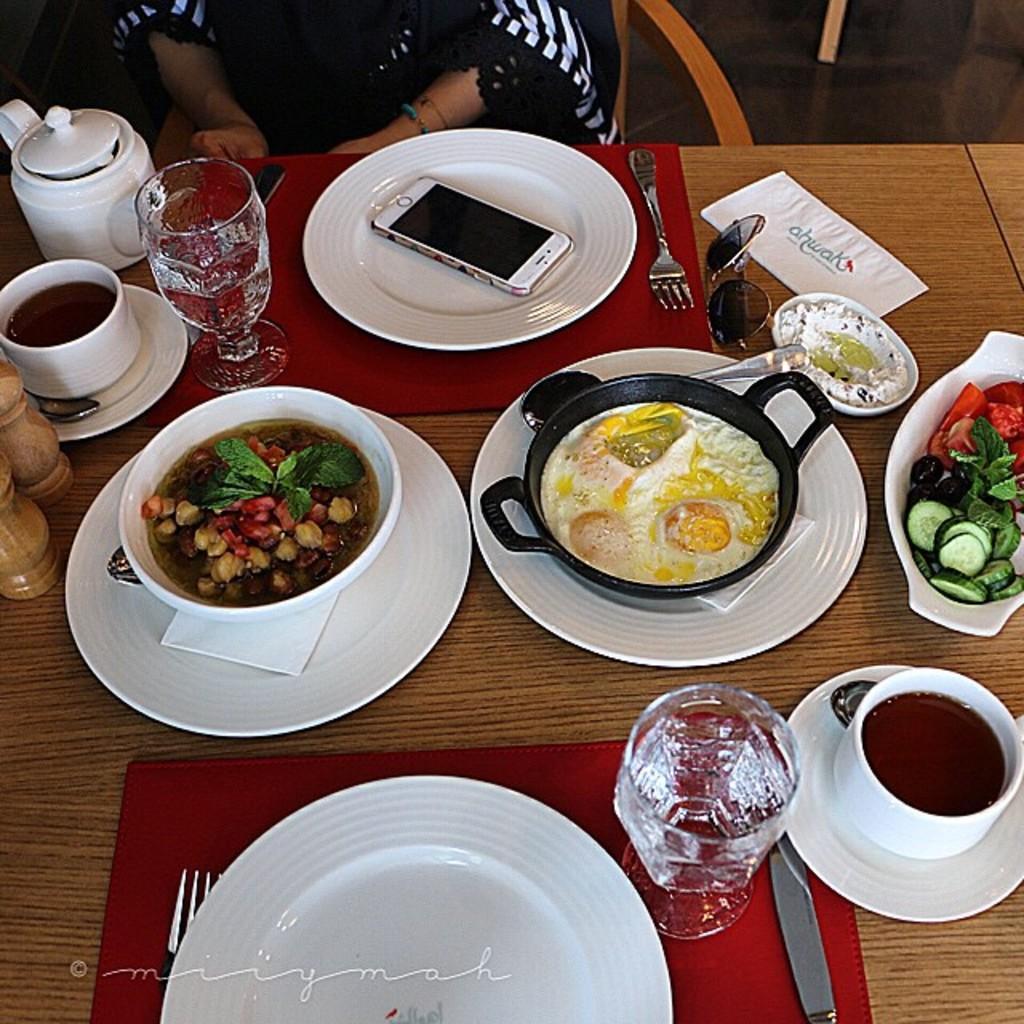In one or two sentences, can you explain what this image depicts? In this image there is a person sitting sitting in-front of the table, where I can see there are some plates with food and also a mobile phone on the plate, coffee cups, fork, glasses and glasses with water. 